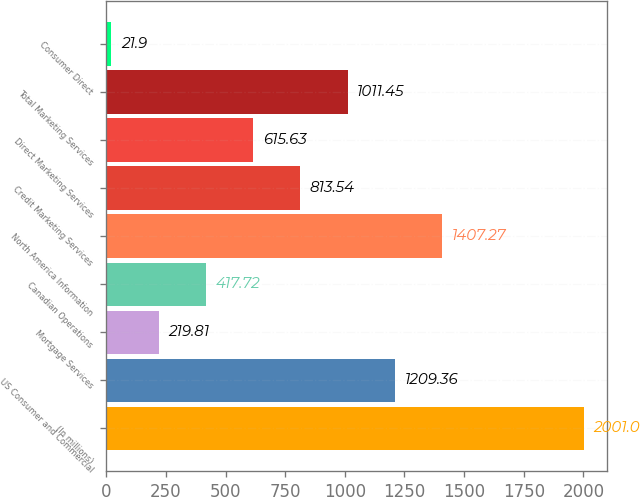Convert chart. <chart><loc_0><loc_0><loc_500><loc_500><bar_chart><fcel>(In millions)<fcel>US Consumer and Commercial<fcel>Mortgage Services<fcel>Canadian Operations<fcel>North America Information<fcel>Credit Marketing Services<fcel>Direct Marketing Services<fcel>Total Marketing Services<fcel>Consumer Direct<nl><fcel>2001<fcel>1209.36<fcel>219.81<fcel>417.72<fcel>1407.27<fcel>813.54<fcel>615.63<fcel>1011.45<fcel>21.9<nl></chart> 